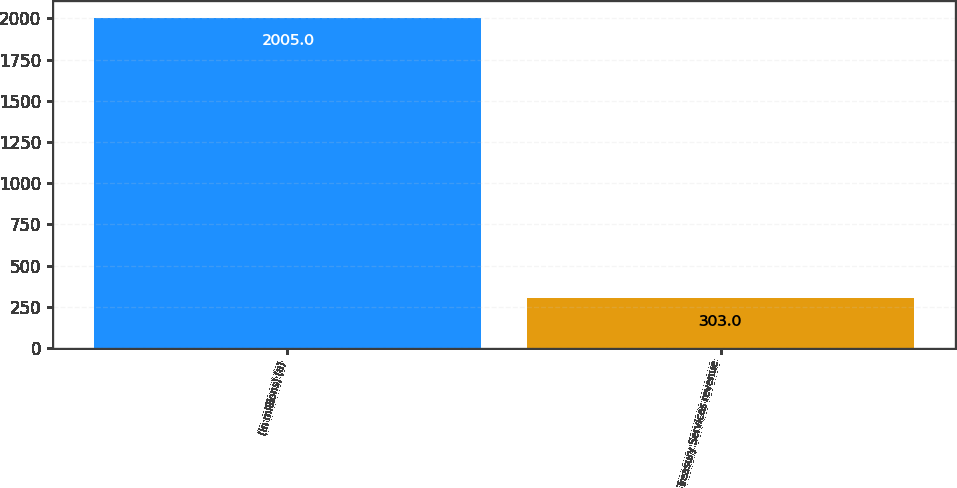Convert chart. <chart><loc_0><loc_0><loc_500><loc_500><bar_chart><fcel>(in millions) (a)<fcel>Treasury Services revenue<nl><fcel>2005<fcel>303<nl></chart> 